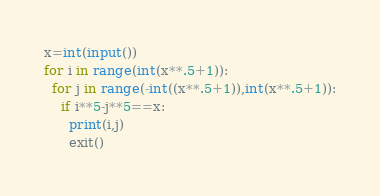<code> <loc_0><loc_0><loc_500><loc_500><_Python_>x=int(input())
for i in range(int(x**.5+1)):
  for j in range(-int((x**.5+1)),int(x**.5+1)):
    if i**5-j**5==x:
      print(i,j)
      exit()</code> 